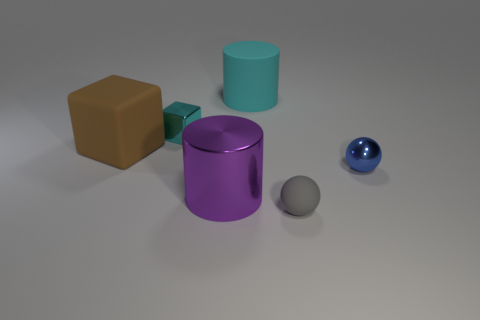Add 3 small red rubber objects. How many objects exist? 9 Subtract all cylinders. How many objects are left? 4 Add 4 small blue objects. How many small blue objects are left? 5 Add 2 tiny cyan balls. How many tiny cyan balls exist? 2 Subtract 0 red spheres. How many objects are left? 6 Subtract all cyan metal cubes. Subtract all big cyan matte cylinders. How many objects are left? 4 